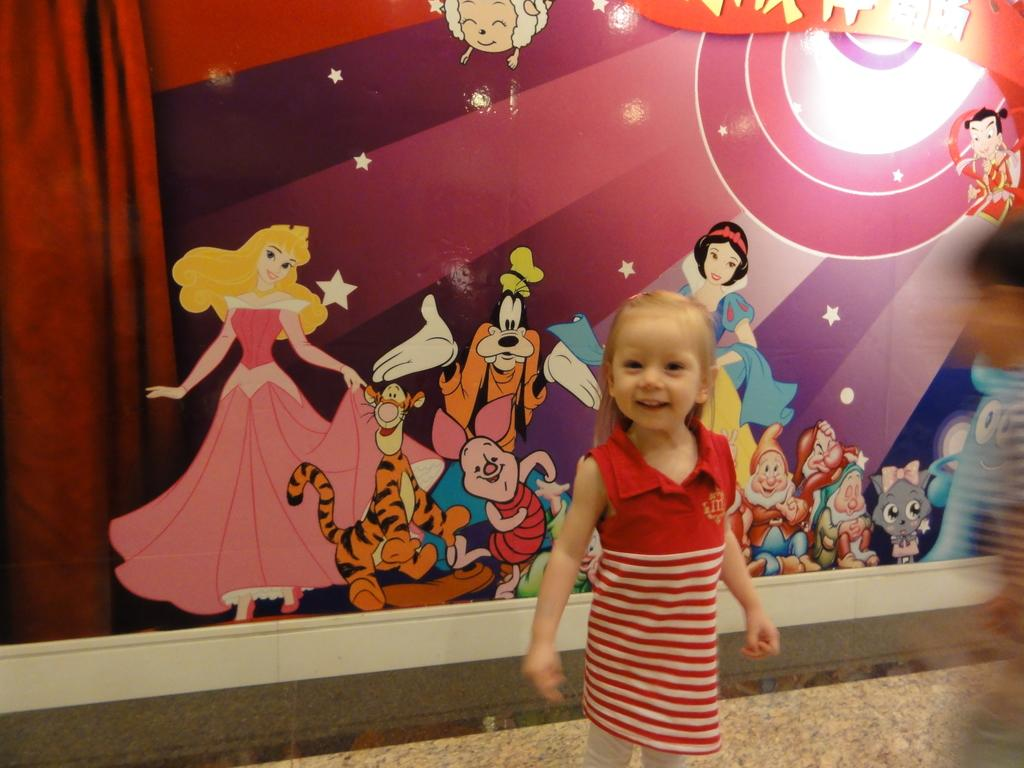What is the main subject of the image? There is a kid standing in the image. What can be seen in the background of the image? There is a poster in the background of the image. What is located on the left side of the image? There is a curtain on the left side of the image. What type of fruit is hanging from the line in the image? There is no line or fruit present in the image. 